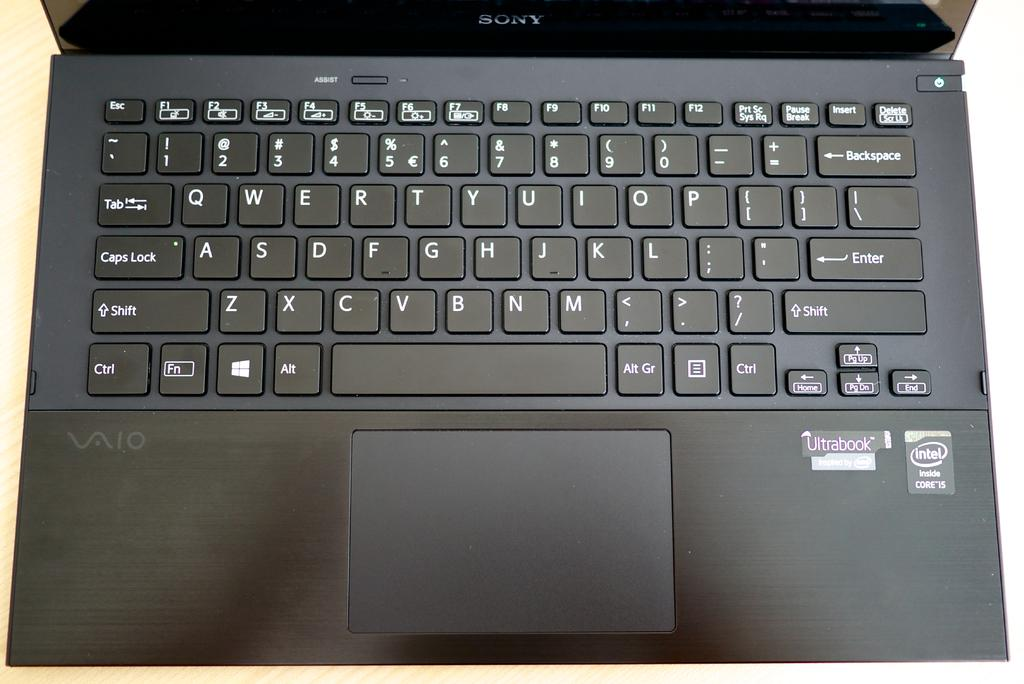<image>
Present a compact description of the photo's key features. a Black Sony laptop VAIO computer close up of the keyboard 